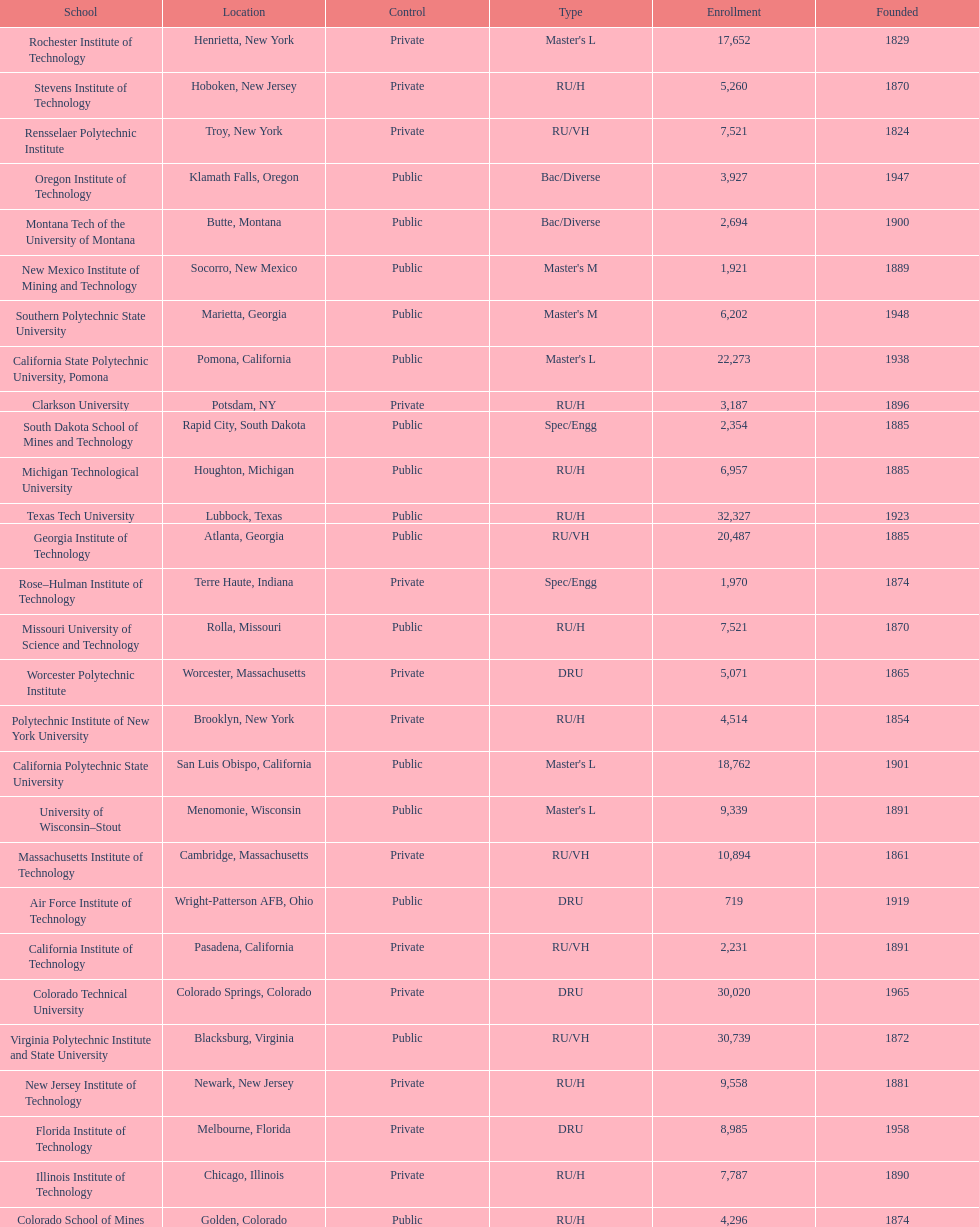What is the total number of schools listed in the table? 28. Would you mind parsing the complete table? {'header': ['School', 'Location', 'Control', 'Type', 'Enrollment', 'Founded'], 'rows': [['Rochester Institute of Technology', 'Henrietta, New York', 'Private', "Master's L", '17,652', '1829'], ['Stevens Institute of Technology', 'Hoboken, New Jersey', 'Private', 'RU/H', '5,260', '1870'], ['Rensselaer Polytechnic Institute', 'Troy, New York', 'Private', 'RU/VH', '7,521', '1824'], ['Oregon Institute of Technology', 'Klamath Falls, Oregon', 'Public', 'Bac/Diverse', '3,927', '1947'], ['Montana Tech of the University of Montana', 'Butte, Montana', 'Public', 'Bac/Diverse', '2,694', '1900'], ['New Mexico Institute of Mining and Technology', 'Socorro, New Mexico', 'Public', "Master's M", '1,921', '1889'], ['Southern Polytechnic State University', 'Marietta, Georgia', 'Public', "Master's M", '6,202', '1948'], ['California State Polytechnic University, Pomona', 'Pomona, California', 'Public', "Master's L", '22,273', '1938'], ['Clarkson University', 'Potsdam, NY', 'Private', 'RU/H', '3,187', '1896'], ['South Dakota School of Mines and Technology', 'Rapid City, South Dakota', 'Public', 'Spec/Engg', '2,354', '1885'], ['Michigan Technological University', 'Houghton, Michigan', 'Public', 'RU/H', '6,957', '1885'], ['Texas Tech University', 'Lubbock, Texas', 'Public', 'RU/H', '32,327', '1923'], ['Georgia Institute of Technology', 'Atlanta, Georgia', 'Public', 'RU/VH', '20,487', '1885'], ['Rose–Hulman Institute of Technology', 'Terre Haute, Indiana', 'Private', 'Spec/Engg', '1,970', '1874'], ['Missouri University of Science and Technology', 'Rolla, Missouri', 'Public', 'RU/H', '7,521', '1870'], ['Worcester Polytechnic Institute', 'Worcester, Massachusetts', 'Private', 'DRU', '5,071', '1865'], ['Polytechnic Institute of New York University', 'Brooklyn, New York', 'Private', 'RU/H', '4,514', '1854'], ['California Polytechnic State University', 'San Luis Obispo, California', 'Public', "Master's L", '18,762', '1901'], ['University of Wisconsin–Stout', 'Menomonie, Wisconsin', 'Public', "Master's L", '9,339', '1891'], ['Massachusetts Institute of Technology', 'Cambridge, Massachusetts', 'Private', 'RU/VH', '10,894', '1861'], ['Air Force Institute of Technology', 'Wright-Patterson AFB, Ohio', 'Public', 'DRU', '719', '1919'], ['California Institute of Technology', 'Pasadena, California', 'Private', 'RU/VH', '2,231', '1891'], ['Colorado Technical University', 'Colorado Springs, Colorado', 'Private', 'DRU', '30,020', '1965'], ['Virginia Polytechnic Institute and State University', 'Blacksburg, Virginia', 'Public', 'RU/VH', '30,739', '1872'], ['New Jersey Institute of Technology', 'Newark, New Jersey', 'Private', 'RU/H', '9,558', '1881'], ['Florida Institute of Technology', 'Melbourne, Florida', 'Private', 'DRU', '8,985', '1958'], ['Illinois Institute of Technology', 'Chicago, Illinois', 'Private', 'RU/H', '7,787', '1890'], ['Colorado School of Mines', 'Golden, Colorado', 'Public', 'RU/H', '4,296', '1874']]} 